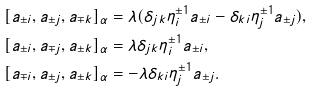Convert formula to latex. <formula><loc_0><loc_0><loc_500><loc_500>[ a _ { \pm i } , a _ { \pm j } , a _ { \mp k } ] _ { \alpha } & = \lambda ( \delta _ { j k } \eta _ { i } ^ { \pm 1 } a _ { \pm i } - \delta _ { k i } \eta _ { j } ^ { \pm 1 } a _ { \pm j } ) , \\ [ a _ { \pm i } , a _ { \mp j } , a _ { \pm k } ] _ { \alpha } & = \lambda \delta _ { j k } \eta _ { i } ^ { \pm 1 } a _ { \pm i } , \\ [ a _ { \mp i } , a _ { \pm j } , a _ { \pm k } ] _ { \alpha } & = - \lambda \delta _ { k i } \eta _ { j } ^ { \pm 1 } a _ { \pm j } .</formula> 